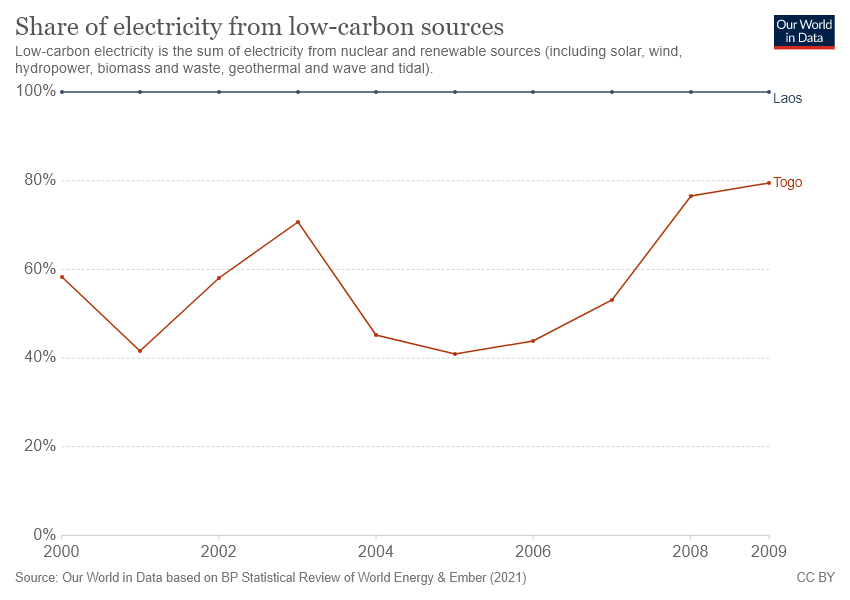What might have caused the sharp decline and later recovery in Togo's low-carbon electricity production? The sharp decline could have been caused by challenges such as technical problems in low-carbon power facilities, funding shortfalls for renewable projects, or policy changes. The recovery might indicate the resolution of such issues or the implementation of new initiatives supporting low-carbon energy development, like international aid programs or government investments aimed at achieving sustainability goals and improving energy security. 